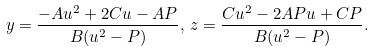Convert formula to latex. <formula><loc_0><loc_0><loc_500><loc_500>y = \frac { - A u ^ { 2 } + 2 C u - A P } { B ( u ^ { 2 } - P ) } , \, z = \frac { C u ^ { 2 } - 2 A P u + C P } { B ( u ^ { 2 } - P ) } .</formula> 